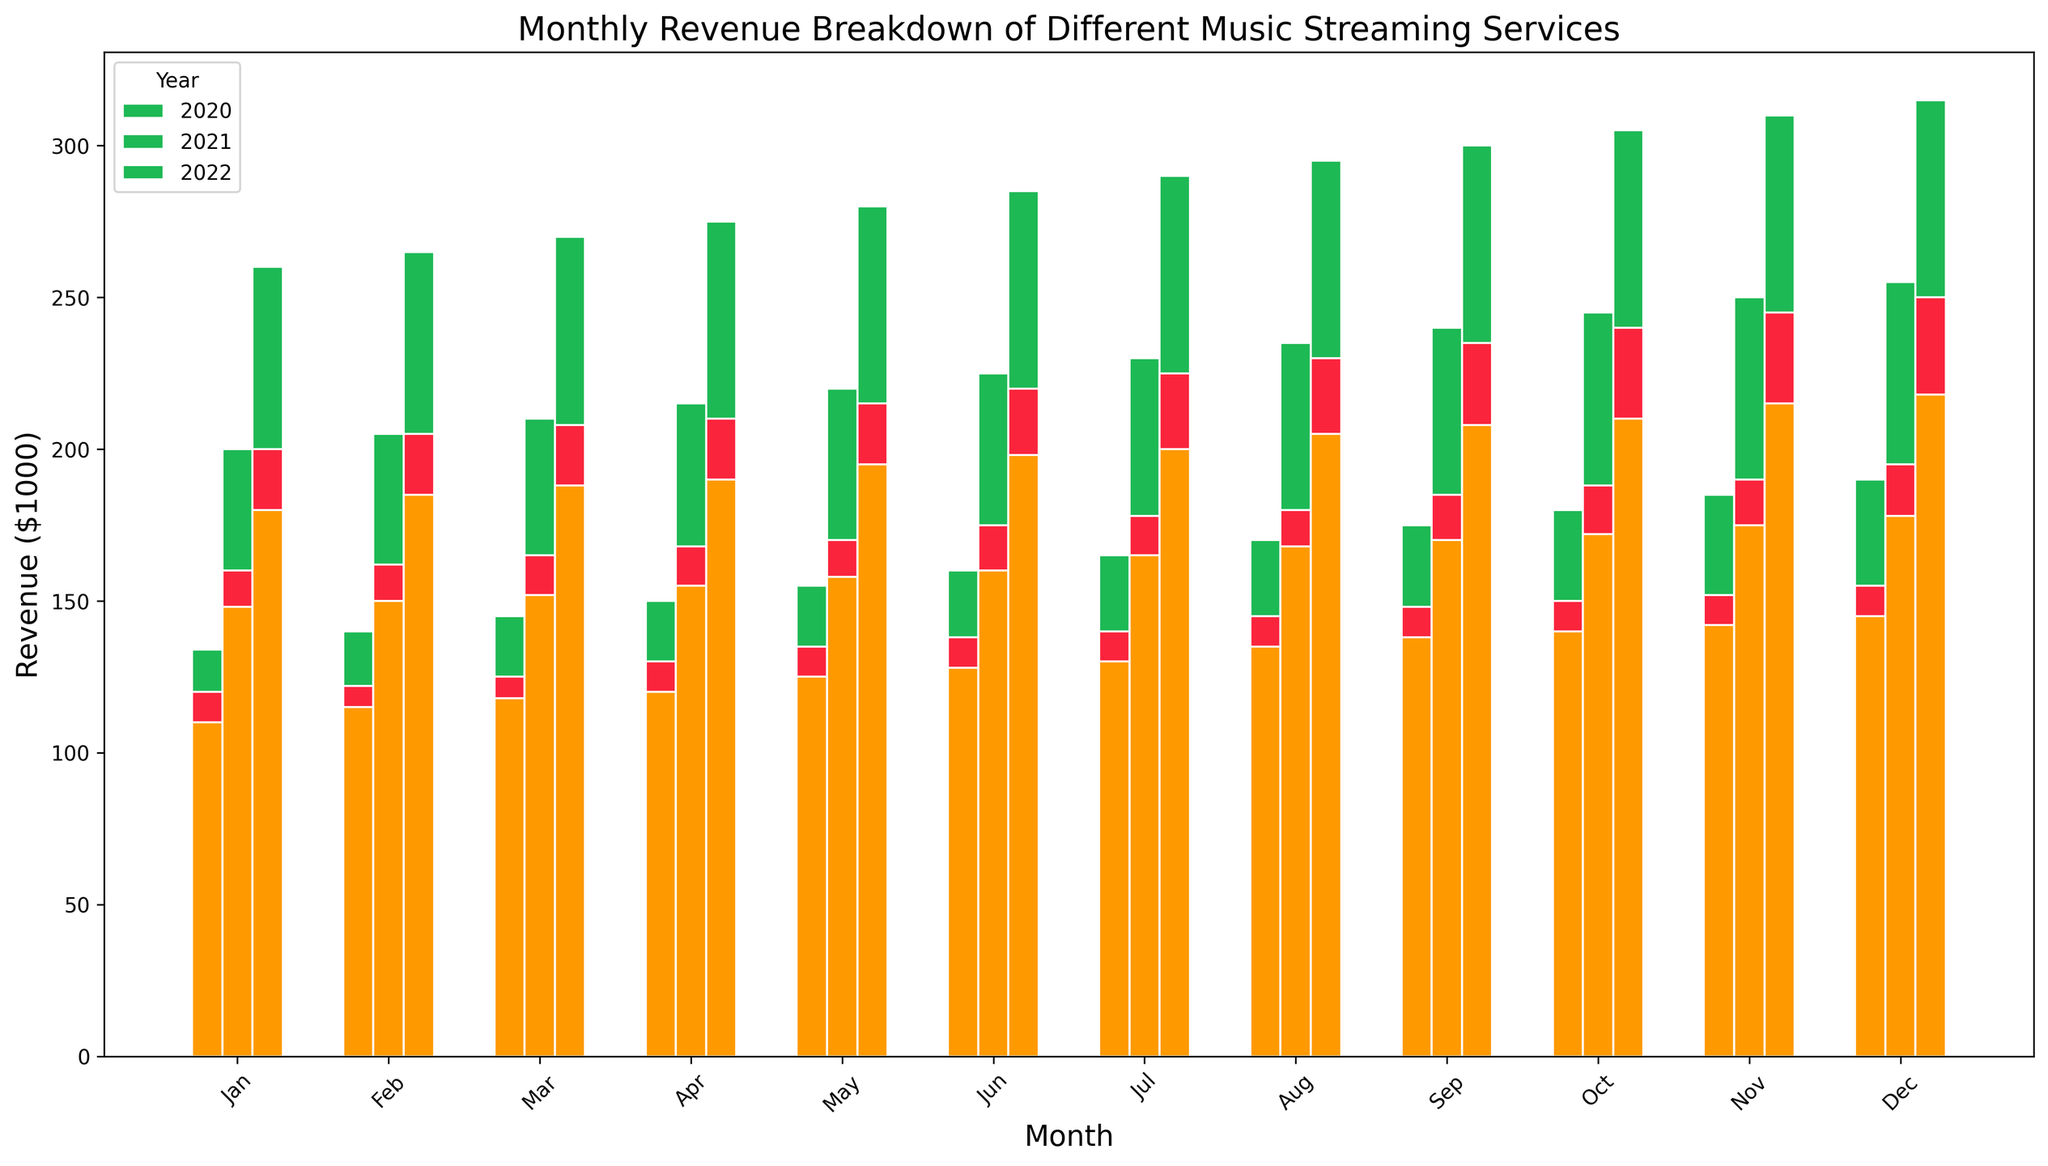Which service showed the most significant revenue increase between Jan 2020 and Dec 2022? To determine this, we observe the revenue difference for each service between Jan 2020 and Dec 2022: Spotify (315-134), Apple Music (250-120), Amazon Music (218-110). Calculating these differences, the increases are 181, 130, and 108 respectively. Therefore, Spotify had the most significant increase.
Answer: Spotify Which month showed the largest revenue for Amazon Music in 2021? To find this, we look at Amazon Music's bars for each month in 2021. December has the highest bar.
Answer: December How does Spotify's revenue in Dec 2020 compare to Apple Music's revenue in Dec 2021? First, identify Spotify's revenue in Dec 2020, which is 190, and then find Apple Music's in Dec 2021, which is 195. Compare the two values: 195 is slightly greater than 190.
Answer: Apple Music's revenue in Dec 2021 is greater What is the average monthly revenue for Apple Music in 2021? To find this, sum the monthly revenues for Apple Music in 2021 (160 + 162 + 165 + 168 + 170 + 175 + 178 + 180 + 185 + 188 + 190 + 195) and divide by 12. This comes to 2116/12 = 176.33.
Answer: 176.33 Which year saw the greatest overall revenue for Spotify? We compare the heights of Spotify's bars across the different years' monthly values. Visually, the bars are highest in 2022.
Answer: 2022 What is the total revenue for Amazon Music across all months in 2022? Add the monthly revenues for Amazon Music in 2022: (180 + 185 + 188 + 190 + 195 + 198 + 200 + 205 + 208 + 210 + 215 + 218). The total is 2392.
Answer: 2392 By how much did Apple Music's revenue increase from Jan 2020 to Dec 2021? Compare Apple Music's revenue in Jan 2020 (120) to Dec 2021 (195). The increase is 195 - 120 = 75.
Answer: 75 Did any service have identical revenue in two different months within 2020? We observe the bars for each month in 2020, noting if any heights are identical for a single service. No identical values for any service are visible.
Answer: No 